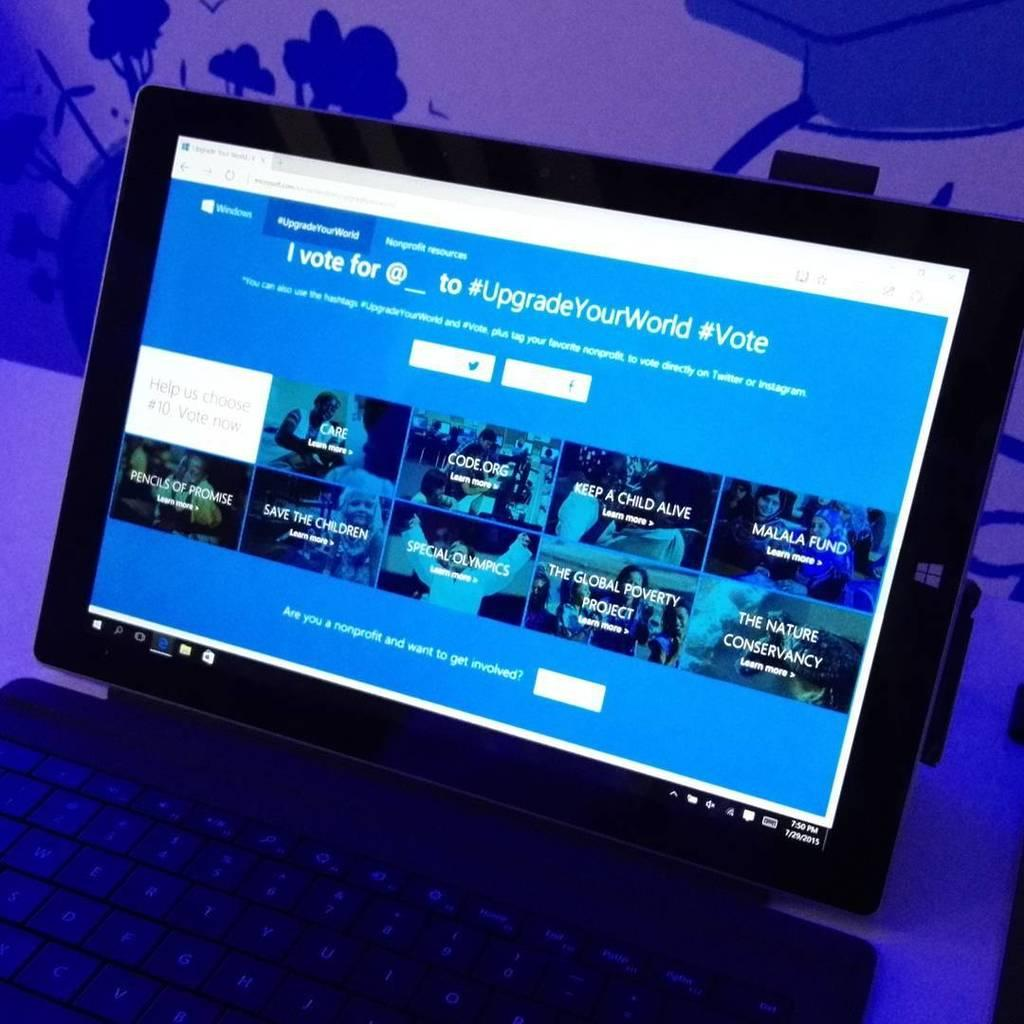<image>
Create a compact narrative representing the image presented. A computer screen says "I vote for" at the top. 